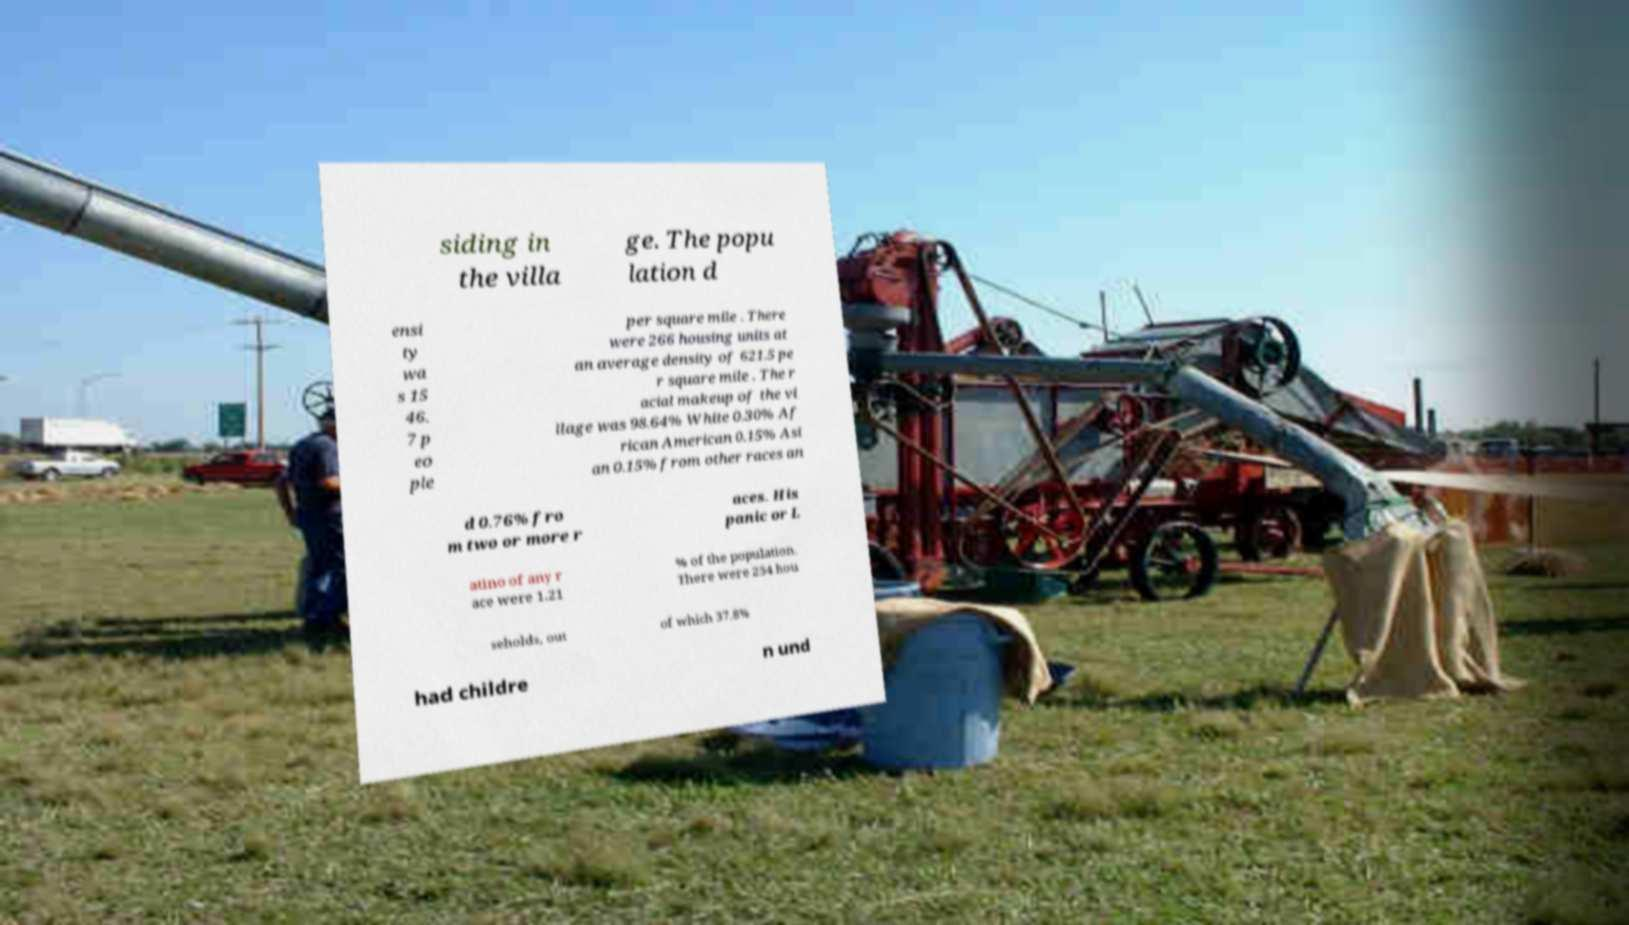Please identify and transcribe the text found in this image. siding in the villa ge. The popu lation d ensi ty wa s 15 46. 7 p eo ple per square mile . There were 266 housing units at an average density of 621.5 pe r square mile . The r acial makeup of the vi llage was 98.64% White 0.30% Af rican American 0.15% Asi an 0.15% from other races an d 0.76% fro m two or more r aces. His panic or L atino of any r ace were 1.21 % of the population. There were 254 hou seholds, out of which 37.8% had childre n und 